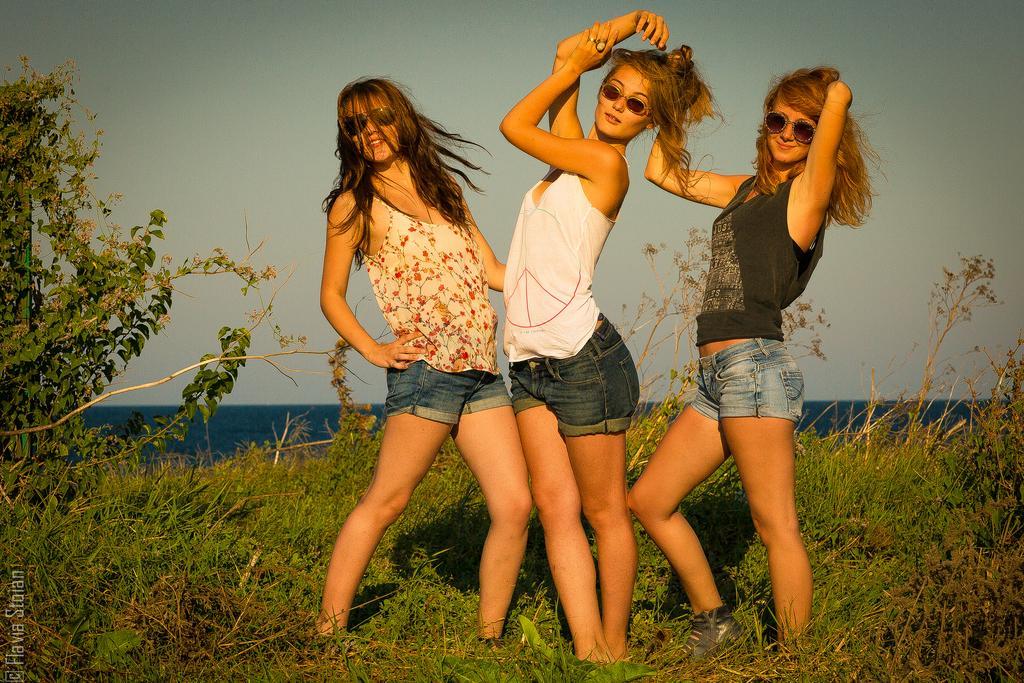In one or two sentences, can you explain what this image depicts? In the image we can see three women standing, wearing clothes, goggles and they are smiling. Here we can see the grass, plant, water and the sky. On the bottom left, we can see the watermark. 